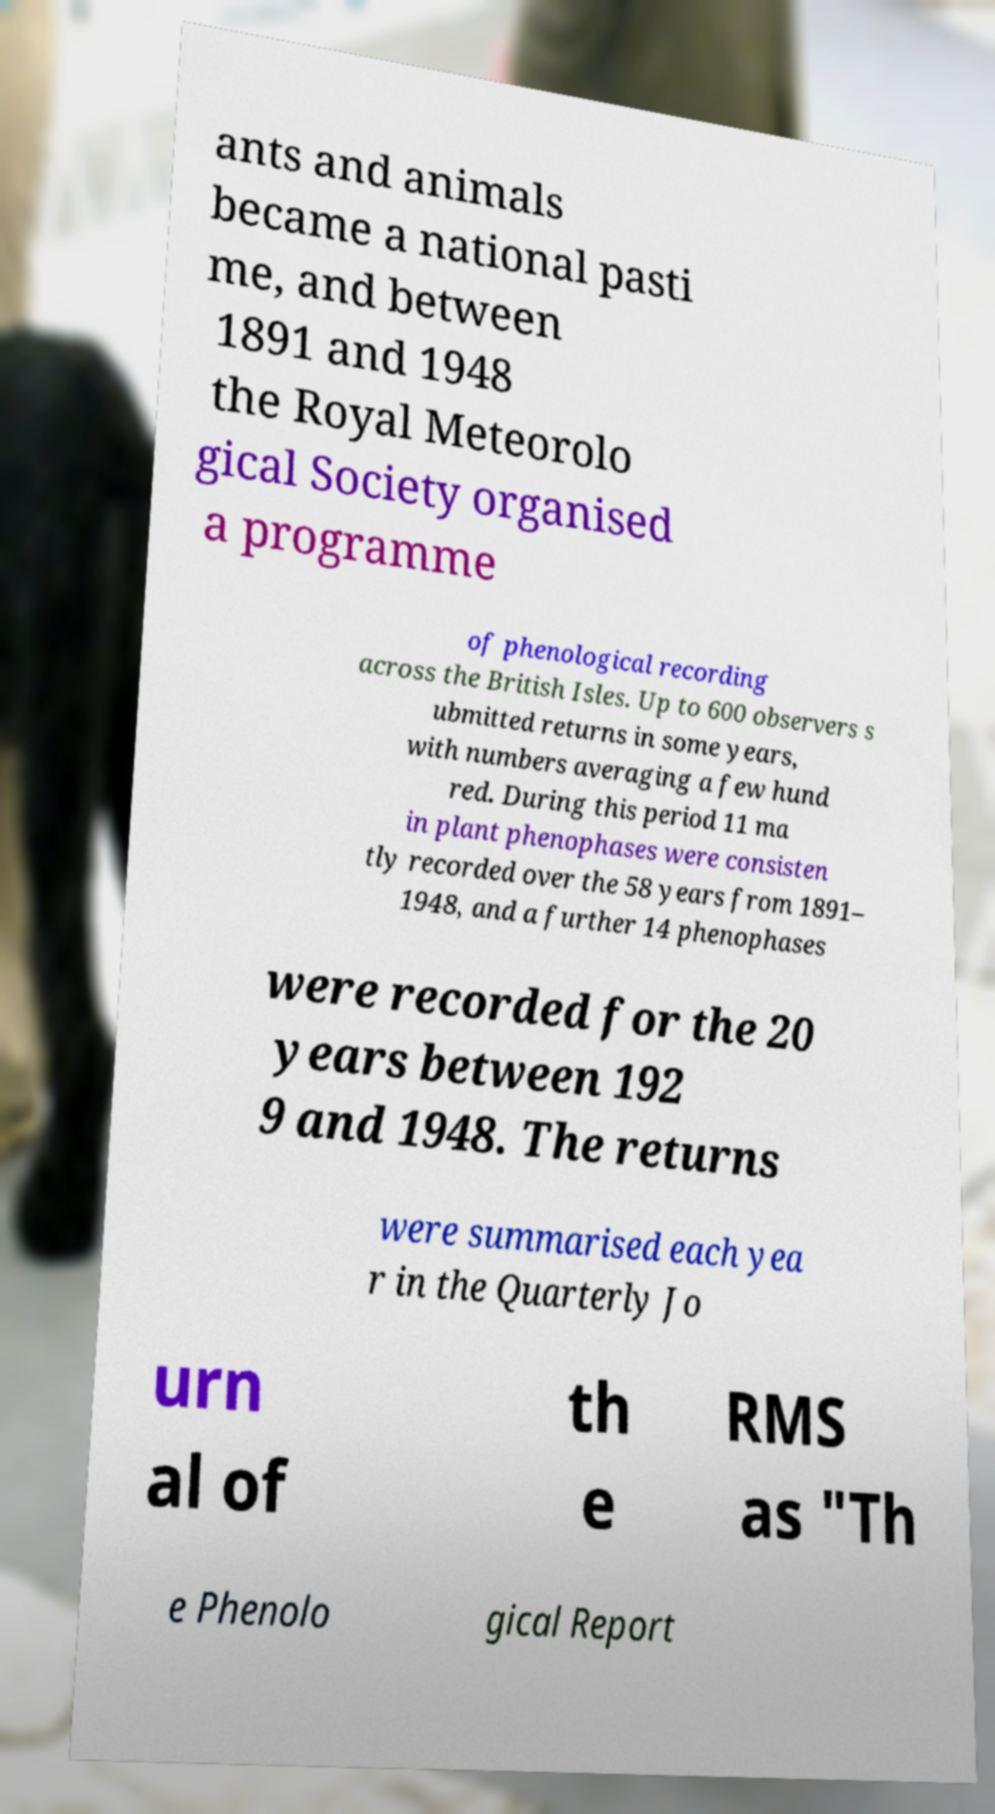Can you accurately transcribe the text from the provided image for me? ants and animals became a national pasti me, and between 1891 and 1948 the Royal Meteorolo gical Society organised a programme of phenological recording across the British Isles. Up to 600 observers s ubmitted returns in some years, with numbers averaging a few hund red. During this period 11 ma in plant phenophases were consisten tly recorded over the 58 years from 1891– 1948, and a further 14 phenophases were recorded for the 20 years between 192 9 and 1948. The returns were summarised each yea r in the Quarterly Jo urn al of th e RMS as "Th e Phenolo gical Report 